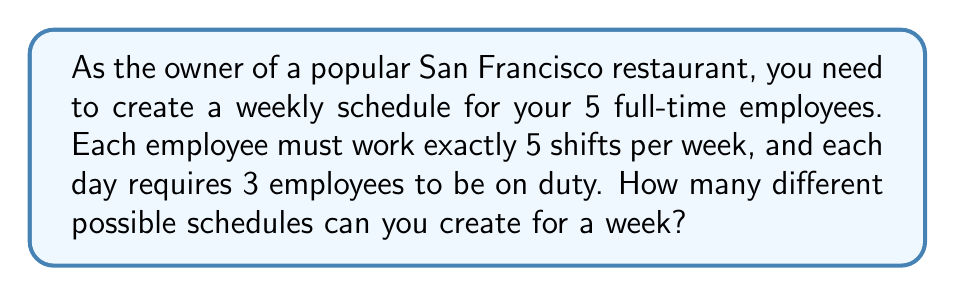What is the answer to this math problem? Let's approach this step-by-step:

1) First, we need to calculate the total number of shifts in a week:
   7 days × 3 employees per day = 21 total shifts

2) We're distributing these 21 shifts among 5 employees, with each employee working 5 shifts.

3) This is a combination problem, specifically a combination with repetition allowed. We can use the stars and bars method.

4) In the stars and bars method, we have:
   - 21 stars (representing the shifts)
   - 4 bars (separating the 5 employees)

5) The formula for combinations with repetition is:

   $$ \binom{n+r-1}{r} \text{ or } \binom{n+r-1}{n-1} $$

   Where n is the number of types (employees in this case) and r is the number of items being chosen (shifts in this case).

6) In our problem:
   n = 5 (employees)
   r = 21 (shifts)

7) Plugging into the formula:

   $$ \binom{5+21-1}{21} = \binom{25}{21} = \binom{25}{4} $$

8) Calculate this combination:

   $$ \binom{25}{4} = \frac{25!}{4!(25-4)!} = \frac{25!}{4!21!} = 12,650 $$

Therefore, there are 12,650 different possible schedules.
Answer: 12,650 